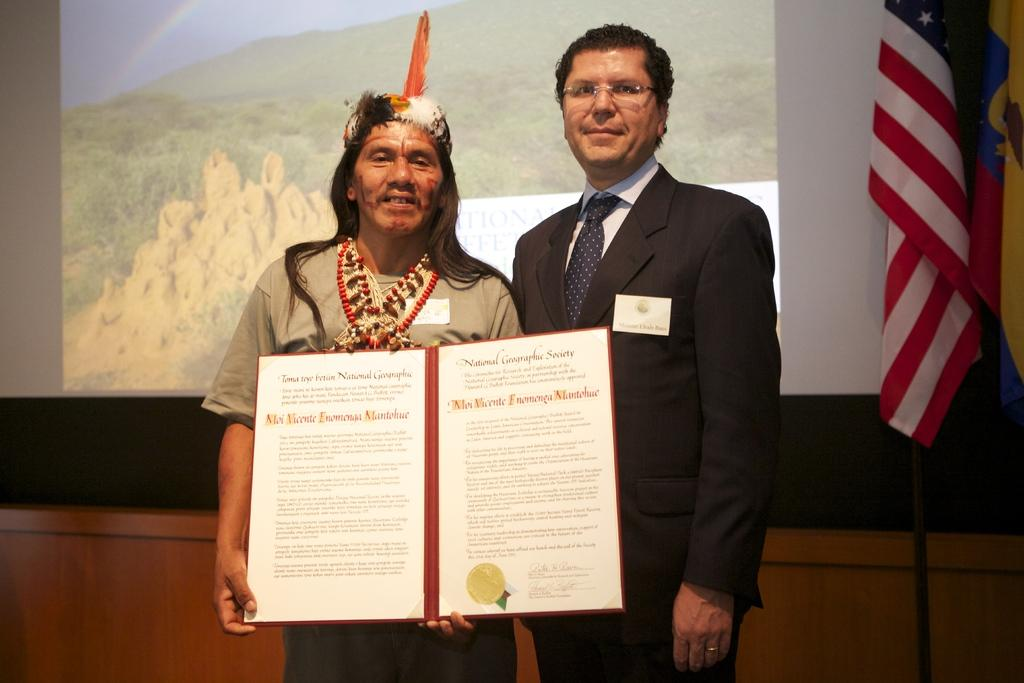How many people are in the image? There are two persons in the image. What is one of the persons holding? One of the persons is holding boards with text. What can be seen in the background of the image? There is a screen in the background of the image. What other objects are present in the image? There are flags in the image. Where is the cushion located in the image? There is no cushion present in the image. What type of hill can be seen in the background of the image? There is no hill visible in the image; it features a screen in the background. 